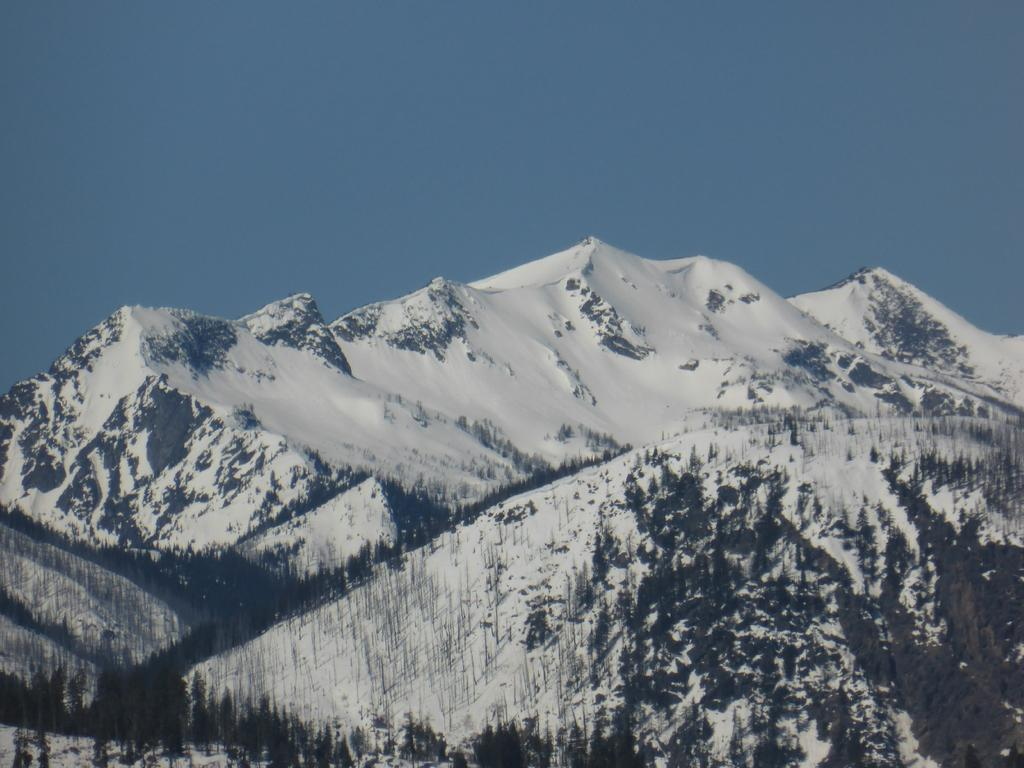What type of natural formation can be seen in the image? There are mountains in the image. What is covering the mountains in the image? There is snow on the mountains. What color is the sky at the top of the image? The sky is blue at the top of the image. What type of coal can be seen in the image? There is no coal present in the image; it features mountains with snow and a blue sky. What flavor of mint is depicted in the image? There is no mint present in the image; it features mountains with snow and a blue sky. 